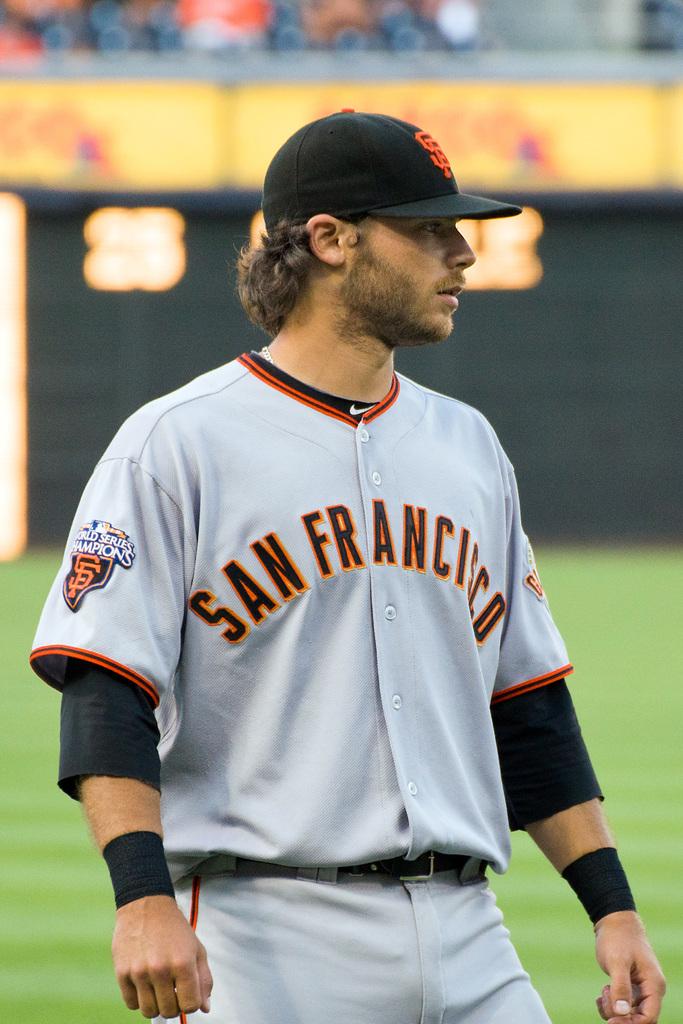What team does he belong to?
Make the answer very short. San francisco. 